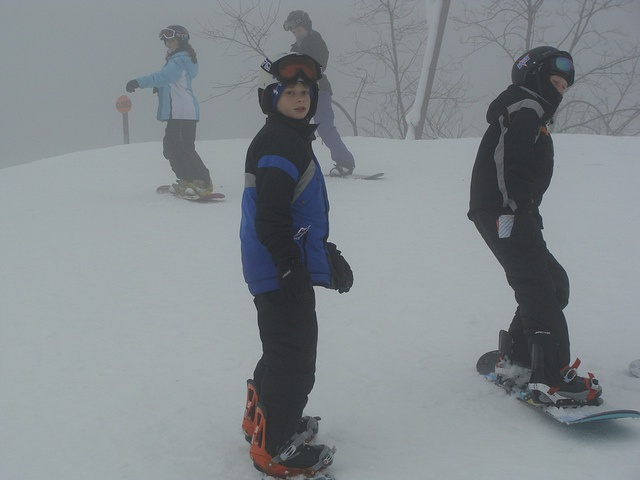Describe the objects in this image and their specific colors. I can see people in gray, black, navy, and darkblue tones, people in gray, black, and darkgray tones, people in gray tones, people in gray tones, and snowboard in gray tones in this image. 